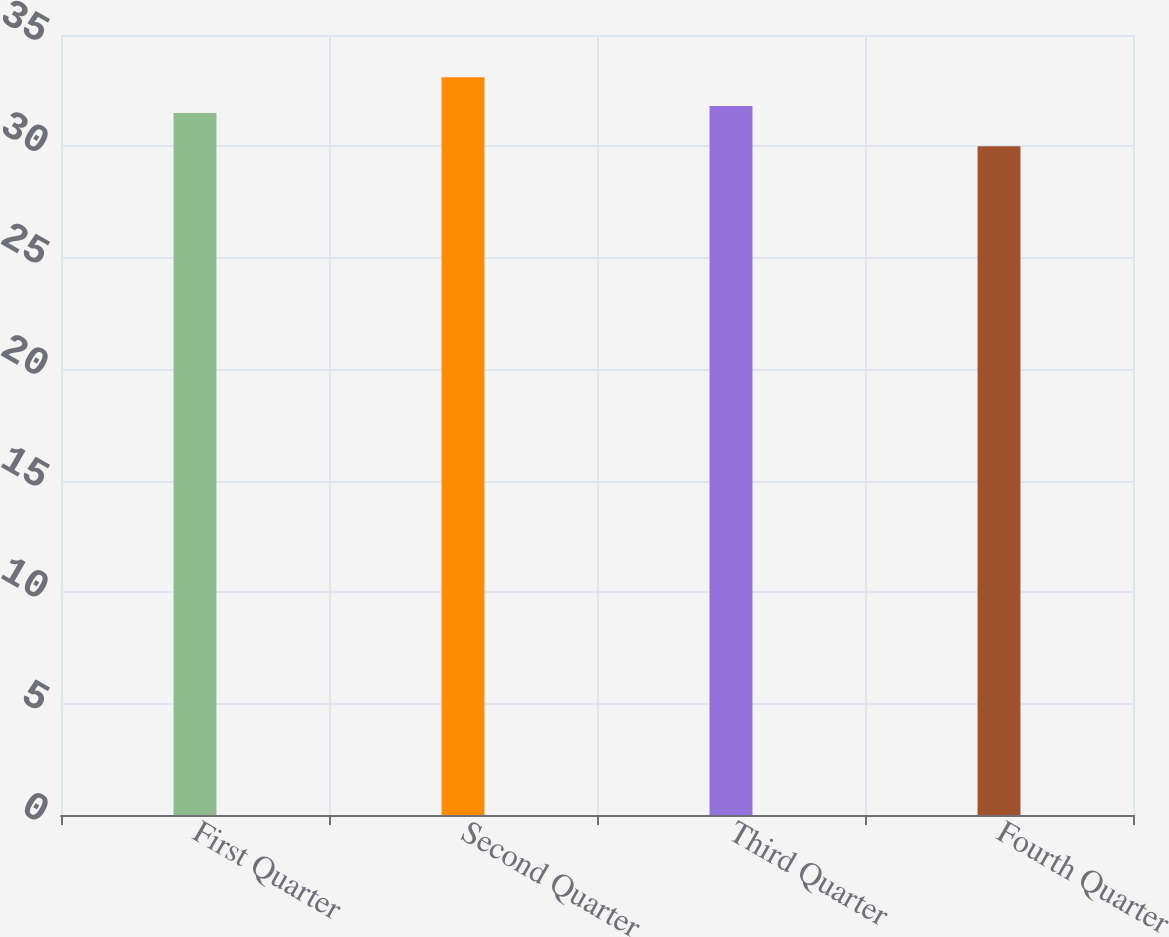Convert chart. <chart><loc_0><loc_0><loc_500><loc_500><bar_chart><fcel>First Quarter<fcel>Second Quarter<fcel>Third Quarter<fcel>Fourth Quarter<nl><fcel>31.5<fcel>33.1<fcel>31.81<fcel>30.01<nl></chart> 